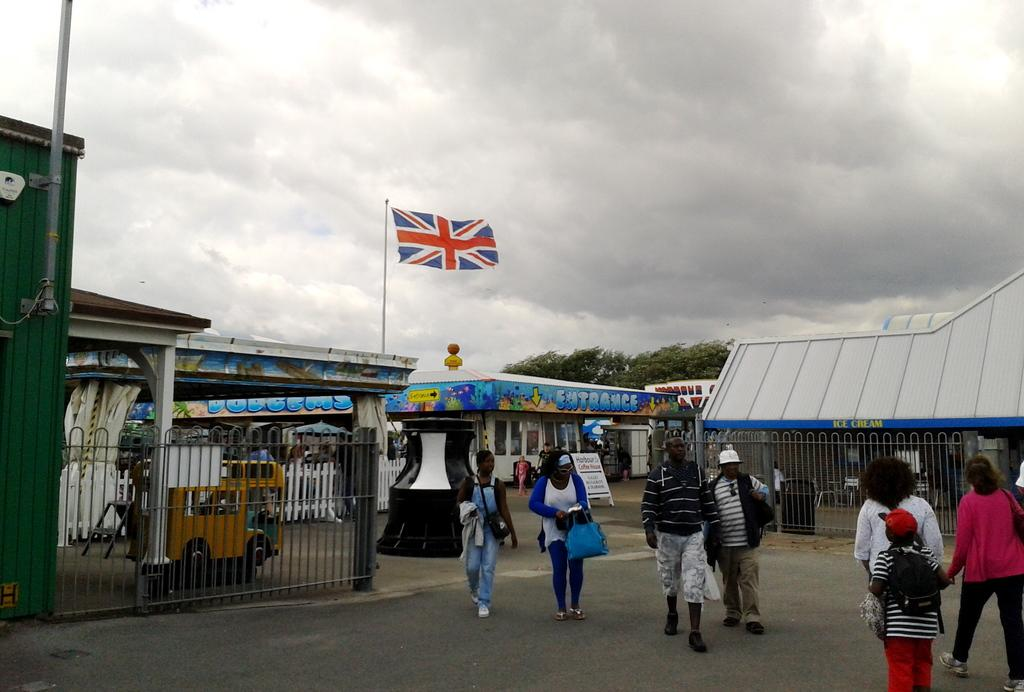<image>
Give a short and clear explanation of the subsequent image. People walking outside a sign that says ENTRANCE. 